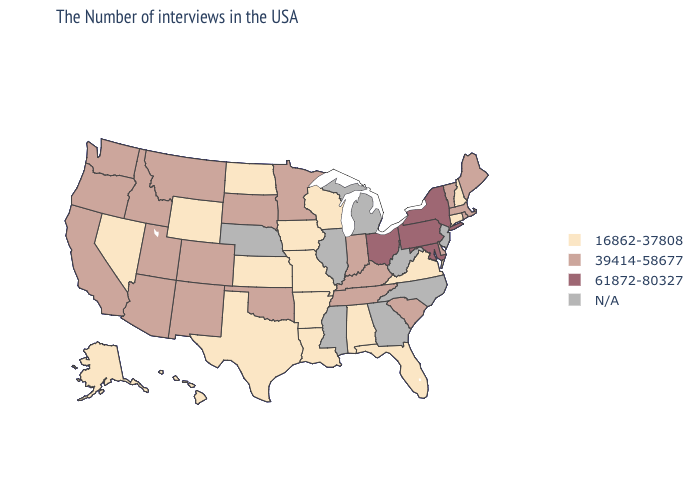Does the map have missing data?
Quick response, please. Yes. What is the highest value in the USA?
Keep it brief. 61872-80327. What is the highest value in states that border New Mexico?
Answer briefly. 39414-58677. Name the states that have a value in the range N/A?
Concise answer only. New Jersey, North Carolina, West Virginia, Georgia, Michigan, Illinois, Mississippi, Nebraska. Name the states that have a value in the range N/A?
Concise answer only. New Jersey, North Carolina, West Virginia, Georgia, Michigan, Illinois, Mississippi, Nebraska. Name the states that have a value in the range 39414-58677?
Be succinct. Maine, Massachusetts, Rhode Island, Vermont, Delaware, South Carolina, Kentucky, Indiana, Tennessee, Minnesota, Oklahoma, South Dakota, Colorado, New Mexico, Utah, Montana, Arizona, Idaho, California, Washington, Oregon. Does the first symbol in the legend represent the smallest category?
Give a very brief answer. Yes. Name the states that have a value in the range N/A?
Write a very short answer. New Jersey, North Carolina, West Virginia, Georgia, Michigan, Illinois, Mississippi, Nebraska. What is the lowest value in the USA?
Give a very brief answer. 16862-37808. Name the states that have a value in the range 61872-80327?
Quick response, please. New York, Maryland, Pennsylvania, Ohio. Name the states that have a value in the range N/A?
Quick response, please. New Jersey, North Carolina, West Virginia, Georgia, Michigan, Illinois, Mississippi, Nebraska. What is the highest value in states that border Utah?
Short answer required. 39414-58677. What is the highest value in the USA?
Answer briefly. 61872-80327. What is the value of Connecticut?
Be succinct. 16862-37808. How many symbols are there in the legend?
Give a very brief answer. 4. 